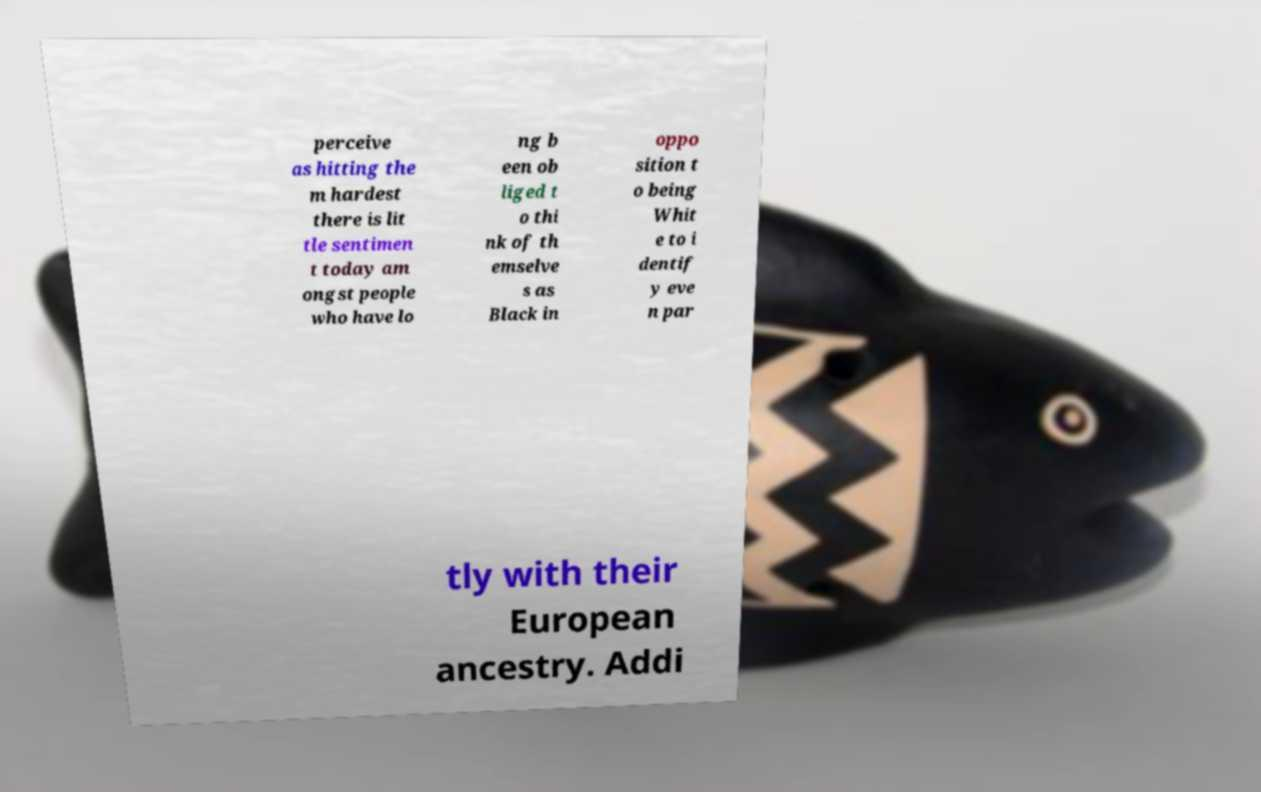What messages or text are displayed in this image? I need them in a readable, typed format. perceive as hitting the m hardest there is lit tle sentimen t today am ongst people who have lo ng b een ob liged t o thi nk of th emselve s as Black in oppo sition t o being Whit e to i dentif y eve n par tly with their European ancestry. Addi 